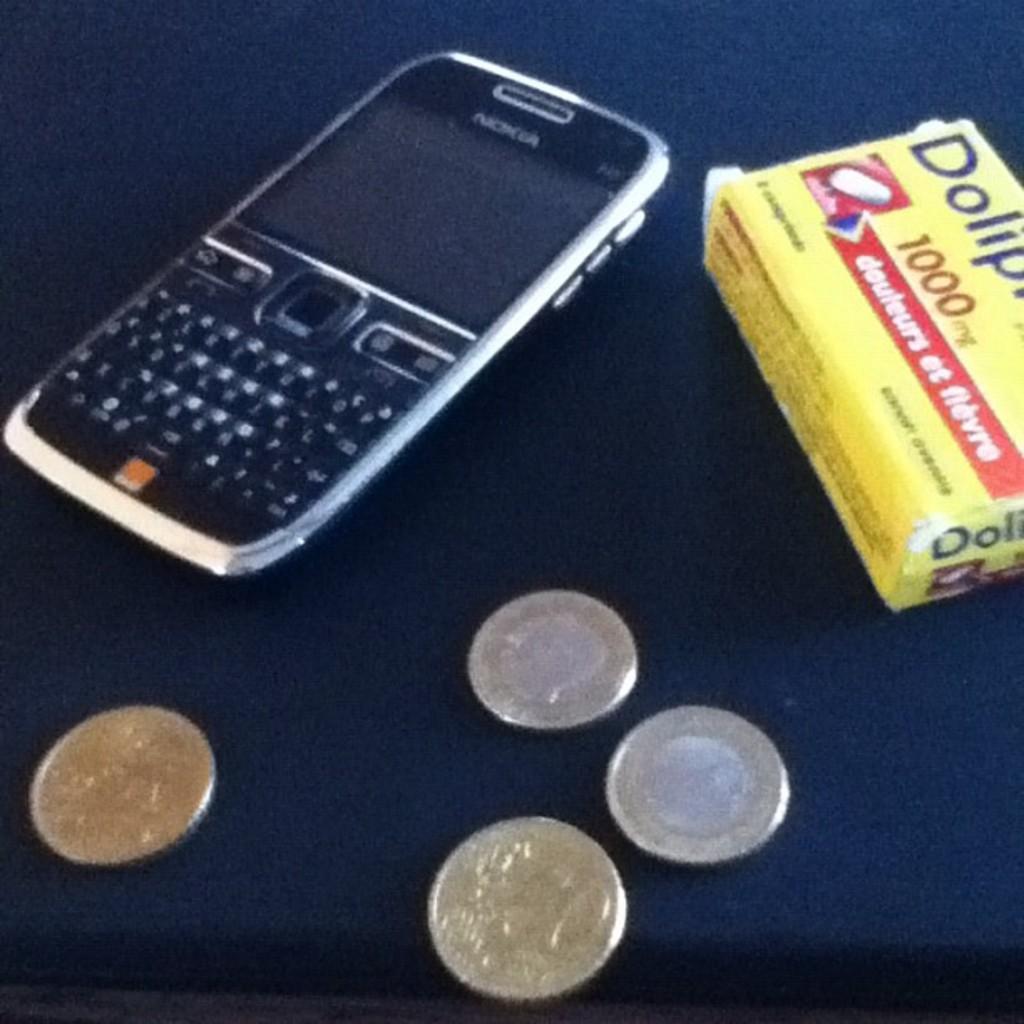How many milligrams of medicine do the pills contain?
Provide a succinct answer. 1000. What make of phone is it?
Offer a very short reply. Nokia. 